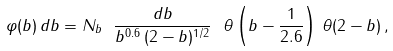<formula> <loc_0><loc_0><loc_500><loc_500>\varphi ( b ) \, d b = N _ { b } \ \frac { d b } { b ^ { 0 . 6 } \, ( 2 - b ) ^ { 1 / 2 } } \ \theta \left ( b - \frac { 1 } { 2 . 6 } \right ) \, \theta ( 2 - b ) \, ,</formula> 